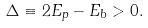Convert formula to latex. <formula><loc_0><loc_0><loc_500><loc_500>\Delta \equiv 2 E _ { p } - E _ { b } > 0 .</formula> 